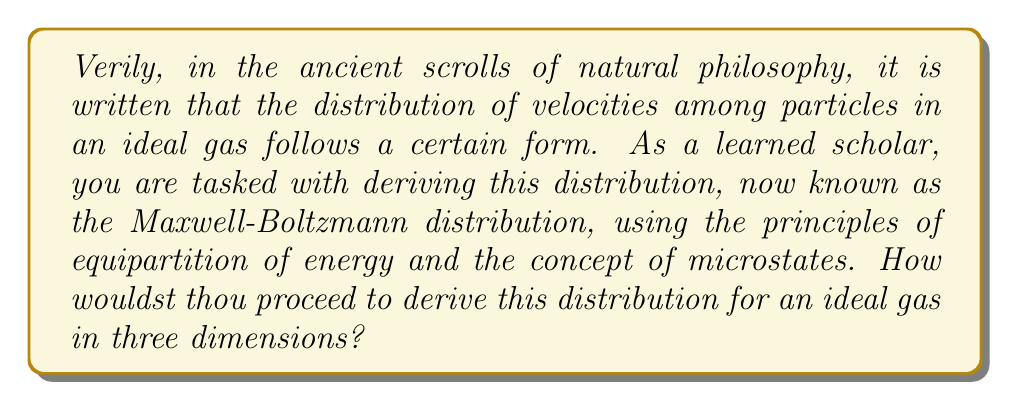Can you solve this math problem? Let us approach this derivation step-by-step, as the sages of old would have done:

1. We begin with the assumption that the energy of a particle is purely kinetic:
   $$E = \frac{1}{2}m(v_x^2 + v_y^2 + v_z^2)$$

2. The probability of finding a particle with velocity components between $v_x$ and $v_x + dv_x$, $v_y$ and $v_y + dv_y$, and $v_z$ and $v_z + dv_z$ is proportional to the number of microstates:
   $$P(v_x, v_y, v_z) dv_x dv_y dv_z \propto e^{-\beta E} dv_x dv_y dv_z$$
   where $\beta = \frac{1}{k_B T}$, $k_B$ is Boltzmann's constant, and $T$ is temperature.

3. Substituting the energy expression:
   $$P(v_x, v_y, v_z) dv_x dv_y dv_z \propto e^{-\frac{\beta m}{2}(v_x^2 + v_y^2 + v_z^2)} dv_x dv_y dv_z$$

4. This can be separated into three independent distributions:
   $$P(v_x, v_y, v_z) = A e^{-\frac{\beta m}{2}v_x^2} \cdot A e^{-\frac{\beta m}{2}v_y^2} \cdot A e^{-\frac{\beta m}{2}v_z^2}$$
   where $A$ is a normalization constant.

5. To find $A$, we normalize each one-dimensional distribution:
   $$\int_{-\infty}^{\infty} A e^{-\frac{\beta m}{2}v_x^2} dv_x = 1$$

6. Solving this integral:
   $$A = \sqrt{\frac{\beta m}{2\pi}}$$

7. The probability distribution for speed $v = \sqrt{v_x^2 + v_y^2 + v_z^2}$ is:
   $$P(v) dv = 4\pi v^2 \cdot \left(\sqrt{\frac{\beta m}{2\pi}}\right)^3 e^{-\frac{\beta m}{2}v^2} dv$$

8. Simplifying:
   $$P(v) = 4\pi \left(\frac{\beta m}{2\pi}\right)^{3/2} v^2 e^{-\frac{\beta m}{2}v^2}$$

9. Substituting $\beta = \frac{1}{k_B T}$:
   $$P(v) = 4\pi \left(\frac{m}{2\pi k_B T}\right)^{3/2} v^2 e^{-\frac{mv^2}{2k_B T}}$$

This final expression is the Maxwell-Boltzmann distribution for the speed of particles in an ideal gas.
Answer: $$P(v) = 4\pi \left(\frac{m}{2\pi k_B T}\right)^{3/2} v^2 e^{-\frac{mv^2}{2k_B T}}$$ 